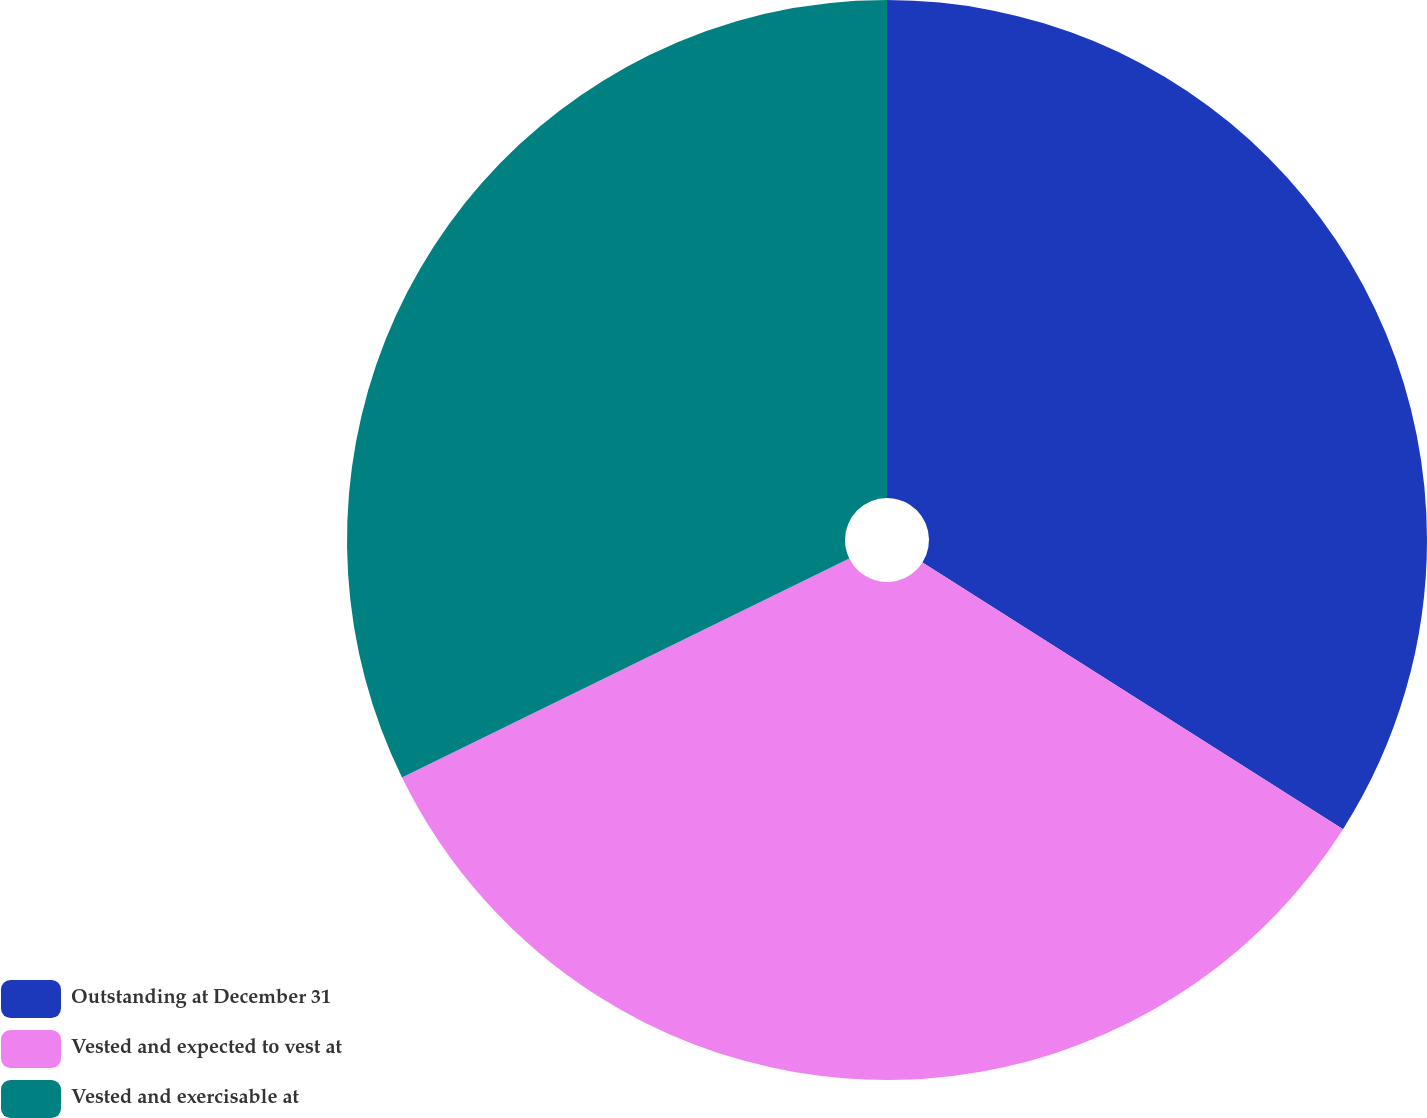Convert chart. <chart><loc_0><loc_0><loc_500><loc_500><pie_chart><fcel>Outstanding at December 31<fcel>Vested and expected to vest at<fcel>Vested and exercisable at<nl><fcel>34.0%<fcel>33.76%<fcel>32.25%<nl></chart> 